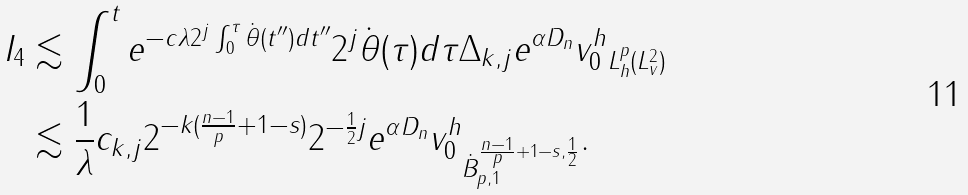<formula> <loc_0><loc_0><loc_500><loc_500>I _ { 4 } & \lesssim \int _ { 0 } ^ { t } e ^ { - c \lambda 2 ^ { j } \int _ { 0 } ^ { \tau } \dot { \theta } ( t ^ { \prime \prime } ) d { t ^ { \prime \prime } } } 2 ^ { j } \dot { \theta } ( \tau ) d \tau \| { \Delta } _ { k , j } e ^ { \alpha D _ { n } } v _ { 0 } ^ { h } \| _ { L ^ { p } _ { h } ( L ^ { 2 } _ { v } ) } \\ & \lesssim \frac { 1 } { \lambda } c _ { k , j } 2 ^ { - k ( \frac { n - 1 } { p } + 1 - s ) } 2 ^ { - \frac { 1 } { 2 } j } \| e ^ { \alpha D _ { n } } v _ { 0 } ^ { h } \| _ { \dot { B } _ { p , 1 } ^ { \frac { n - 1 } { p } + 1 - s , \frac { 1 } { 2 } } } .</formula> 